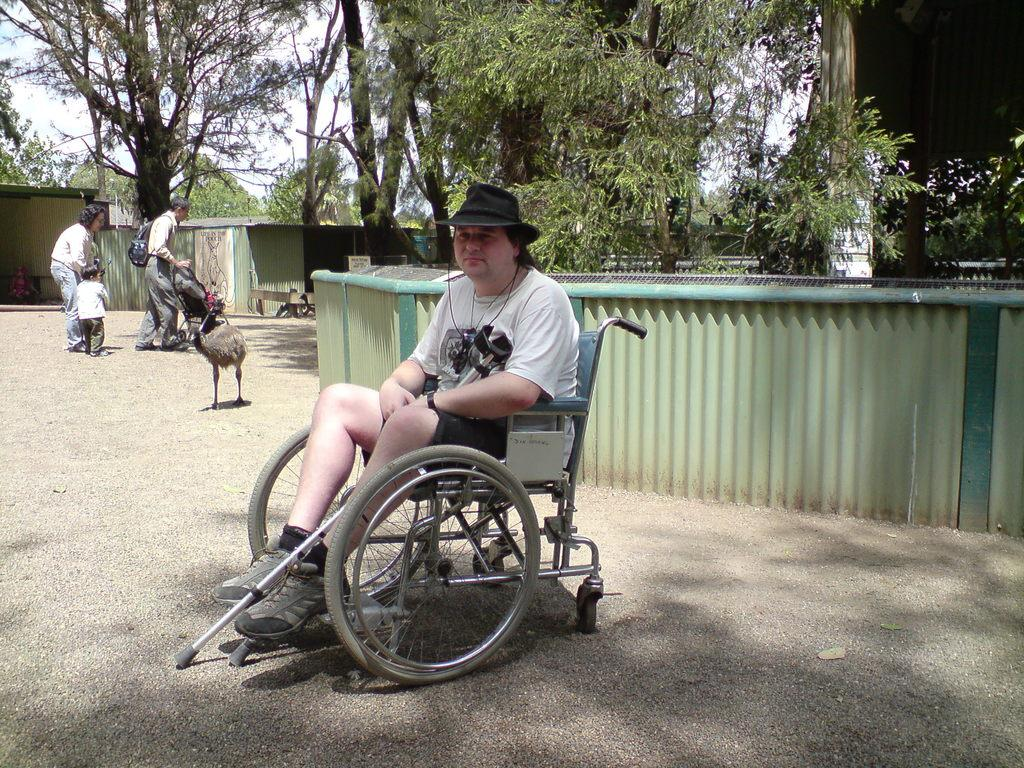What is the person in the wheelchair holding in the image? The person is holding something, but the specific object cannot be determined from the image. What can be seen in the background of the image? There are trees, fencing, sheds, and a bird visible in the background. What are the people in the background doing? The people in the background are walking and holding something, but the specific object cannot be determined from the image. Can you see a kitty playing with a range and a nut in the image? No, there is no kitty, range, or nut present in the image. 